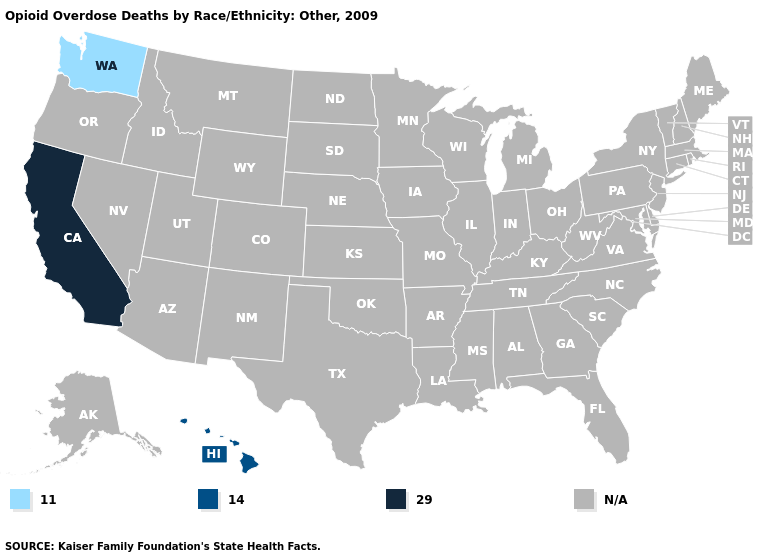Does California have the lowest value in the USA?
Be succinct. No. What is the value of Nevada?
Answer briefly. N/A. Does Washington have the lowest value in the USA?
Answer briefly. Yes. Does the first symbol in the legend represent the smallest category?
Concise answer only. Yes. Is the legend a continuous bar?
Give a very brief answer. No. Name the states that have a value in the range 11.0?
Short answer required. Washington. Name the states that have a value in the range 29.0?
Keep it brief. California. What is the value of South Dakota?
Give a very brief answer. N/A. Name the states that have a value in the range 29.0?
Quick response, please. California. What is the value of Mississippi?
Be succinct. N/A. 